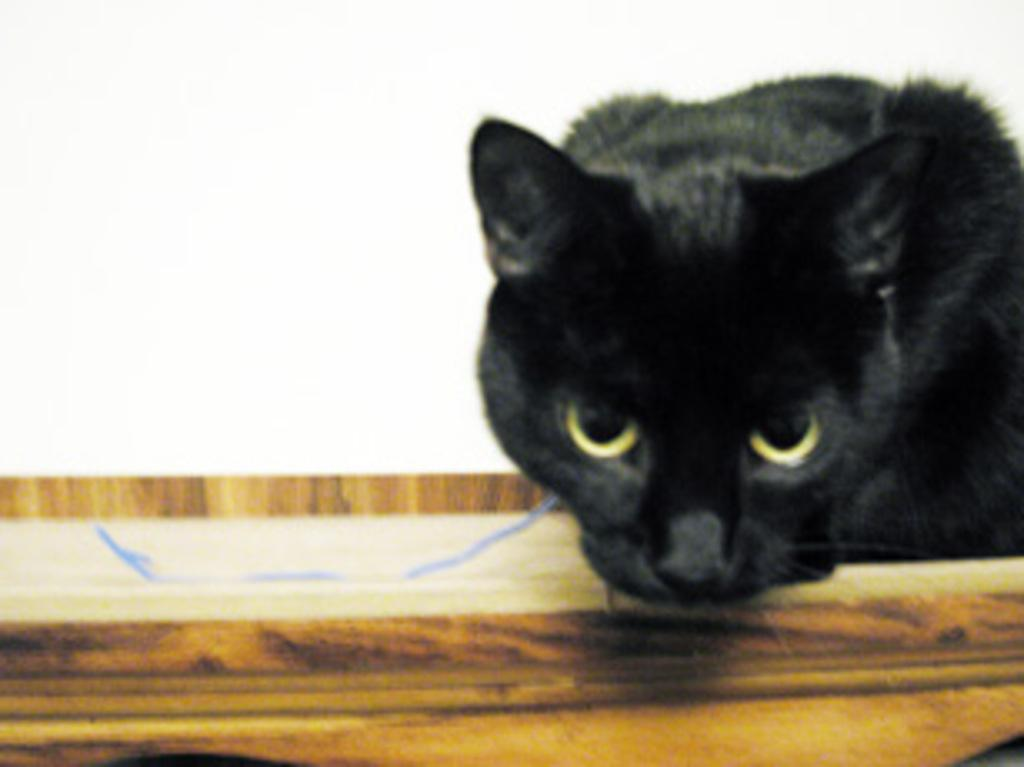What type of animal is in the image? There is a black cat in the image. What is the cat sitting or standing on? The cat is on a wooden object. What color is the background of the image? The background of the image is white. Is the cat's grandmother reading a book in the image? There is no mention of a grandmother or reading in the image, and the focus is solely on the black cat and its position on the wooden object. 